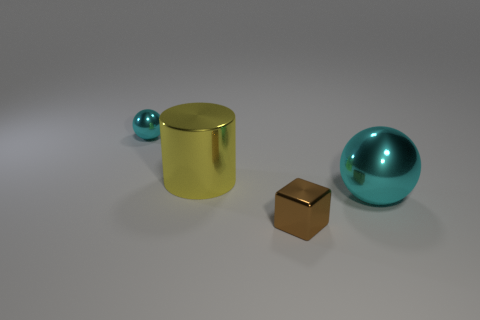Is the tiny metal sphere the same color as the shiny block?
Keep it short and to the point. No. Are there the same number of tiny things that are behind the brown shiny object and purple things?
Your answer should be very brief. No. Is the size of the metallic ball on the left side of the metallic cube the same as the large yellow thing?
Your answer should be compact. No. There is a big cyan metal sphere; what number of tiny things are in front of it?
Provide a short and direct response. 1. There is a object that is both behind the cube and on the right side of the big cylinder; what is it made of?
Provide a short and direct response. Metal. How many big things are either gray shiny balls or cyan metal spheres?
Your answer should be compact. 1. What is the size of the yellow metallic thing?
Your answer should be very brief. Large. The brown metallic thing has what shape?
Offer a terse response. Cube. Is there any other thing that has the same shape as the yellow object?
Your answer should be compact. No. Is the number of tiny cyan shiny balls to the right of the small metallic cube less than the number of shiny spheres?
Give a very brief answer. Yes. 